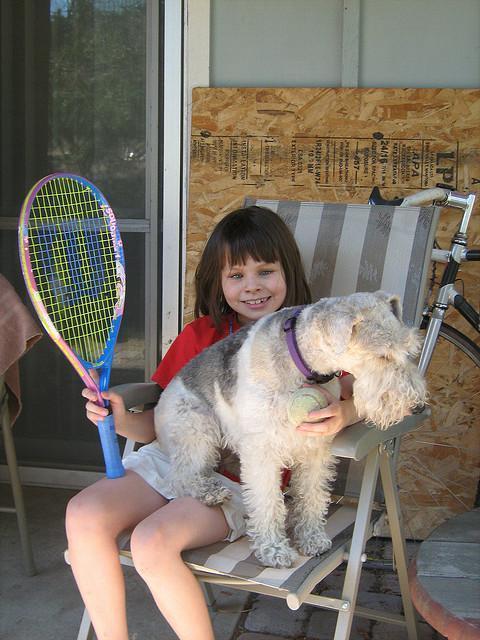How many dogs?
Give a very brief answer. 1. How many white teddy bears in this image?
Give a very brief answer. 0. 